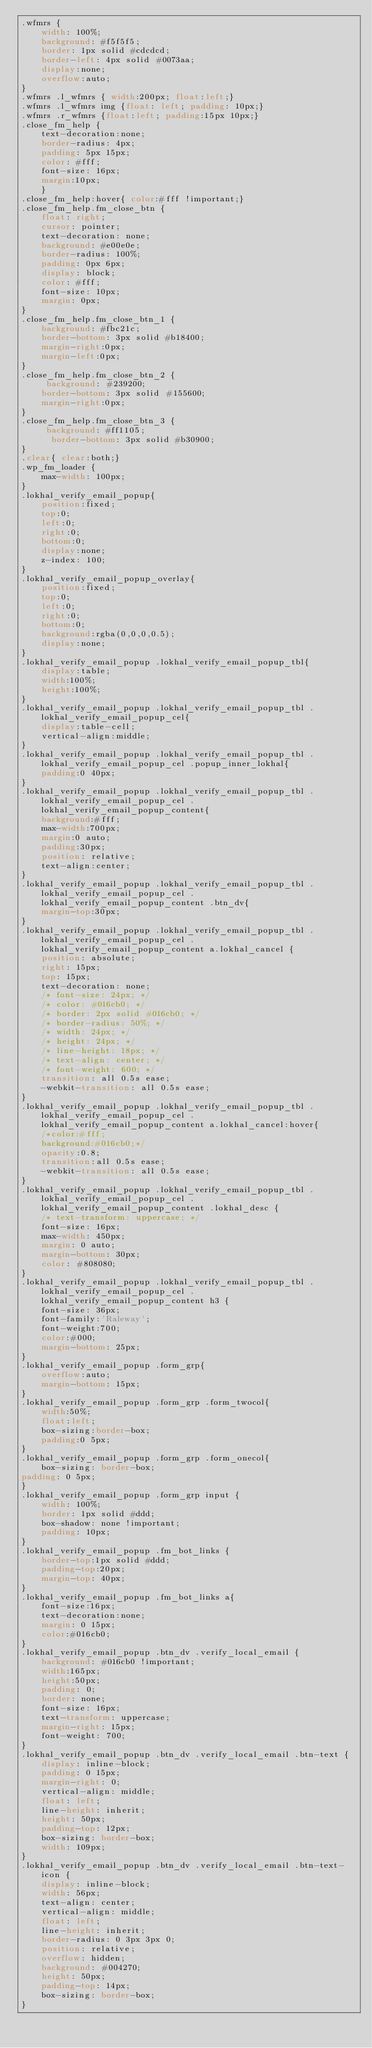Convert code to text. <code><loc_0><loc_0><loc_500><loc_500><_CSS_>.wfmrs {
 	width: 100%;
    background: #f5f5f5;
    border: 1px solid #cdcdcd;
    border-left: 4px solid #0073aa;
	display:none;
	overflow:auto;
}
.wfmrs .l_wfmrs { width:200px; float:left;}
.wfmrs .l_wfmrs img {float: left; padding: 10px;}
.wfmrs .r_wfmrs {float:left; padding:15px 10px;}
.close_fm_help {
	text-decoration:none;
    border-radius: 4px;
	padding: 5px 15px;
	color: #fff;
	font-size: 16px;
	margin:10px;
	}
.close_fm_help:hover{ color:#fff !important;}
.close_fm_help.fm_close_btn {
   	float: right;
    cursor: pointer;
    text-decoration: none;
    background: #e00e0e;
    border-radius: 100%;
    padding: 0px 6px;
    display: block;
    color: #fff;
    font-size: 10px;
	margin: 0px;
}
.close_fm_help.fm_close_btn_1 {
    background: #fbc21c;
    border-bottom: 3px solid #b18400;
	margin-right:0px;
	margin-left:0px;
}
.close_fm_help.fm_close_btn_2 {
	 background: #239200;
	border-bottom: 3px solid #155600;
	margin-right:0px;
}
.close_fm_help.fm_close_btn_3 {
	 background: #ff1105;
	  border-bottom: 3px solid #b30900;
}
.clear{ clear:both;}
.wp_fm_loader {
	max-width: 100px;
}
.lokhal_verify_email_popup{
	position:fixed;
	top:0;
	left:0;
	right:0;
	bottom:0;
	display:none;
	z-index: 100;
}
.lokhal_verify_email_popup_overlay{
	position:fixed;
	top:0;
	left:0;
	right:0;
	bottom:0;
	background:rgba(0,0,0,0.5);
	display:none;
}
.lokhal_verify_email_popup .lokhal_verify_email_popup_tbl{
	display:table;
	width:100%;
	height:100%;
}
.lokhal_verify_email_popup .lokhal_verify_email_popup_tbl .lokhal_verify_email_popup_cel{
	display:table-cell;
	vertical-align:middle;
}
.lokhal_verify_email_popup .lokhal_verify_email_popup_tbl .lokhal_verify_email_popup_cel .popup_inner_lokhal{
	padding:0 40px;
}
.lokhal_verify_email_popup .lokhal_verify_email_popup_tbl .lokhal_verify_email_popup_cel .lokhal_verify_email_popup_content{
	background:#fff;
	max-width:700px;
	margin:0 auto;
	padding:30px;
	position: relative;
	text-align:center;
}
.lokhal_verify_email_popup .lokhal_verify_email_popup_tbl .lokhal_verify_email_popup_cel .lokhal_verify_email_popup_content .btn_dv{
	margin-top:30px;
}
.lokhal_verify_email_popup .lokhal_verify_email_popup_tbl .lokhal_verify_email_popup_cel .lokhal_verify_email_popup_content a.lokhal_cancel {
	position: absolute;
	right: 15px;
	top: 15px;
	text-decoration: none;
	/* font-size: 24px; */
	/* color: #016cb0; */
	/* border: 2px solid #016cb0; */
	/* border-radius: 50%; */
	/* width: 24px; */
	/* height: 24px; */
	/* line-height: 18px; */
	/* text-align: center; */
	/* font-weight: 600; */
	transition: all 0.5s ease;
	-webkit-transition: all 0.5s ease;
}
.lokhal_verify_email_popup .lokhal_verify_email_popup_tbl .lokhal_verify_email_popup_cel .lokhal_verify_email_popup_content a.lokhal_cancel:hover{
	/*color:#fff;
	background:#016cb0;*/
	opacity:0.8;
	transition:all 0.5s ease;
	-webkit-transition: all 0.5s ease;
}
.lokhal_verify_email_popup .lokhal_verify_email_popup_tbl .lokhal_verify_email_popup_cel .lokhal_verify_email_popup_content .lokhal_desc {
	/* text-transform: uppercase; */
	font-size: 16px;
	max-width: 450px;
	margin: 0 auto;
	margin-bottom: 30px;
	color: #808080;
}
.lokhal_verify_email_popup .lokhal_verify_email_popup_tbl .lokhal_verify_email_popup_cel .lokhal_verify_email_popup_content h3 {
	font-size: 36px;
	font-family:'Raleway';
	font-weight:700;
	color:#000;
	margin-bottom: 25px;
}
.lokhal_verify_email_popup .form_grp{
	overflow:auto;
	margin-bottom: 15px;
}
.lokhal_verify_email_popup .form_grp .form_twocol{
	width:50%;
	float:left;
	box-sizing:border-box;
	padding:0 5px;
}
.lokhal_verify_email_popup .form_grp .form_onecol{
	box-sizing: border-box;
padding: 0 5px;
}
.lokhal_verify_email_popup .form_grp input {
	width: 100%;
	border: 1px solid #ddd;
	box-shadow: none !important;
	padding: 10px;
}
.lokhal_verify_email_popup .fm_bot_links {
	border-top:1px solid #ddd;
	padding-top:20px;
	margin-top: 40px;
}
.lokhal_verify_email_popup .fm_bot_links a{
	font-size:16px;
	text-decoration:none;
	margin: 0 15px;
	color:#016cb0;
}
.lokhal_verify_email_popup .btn_dv .verify_local_email {
	background: #016cb0 !important;
	width:165px;
	height:50px;
	padding: 0;
	border: none;
	font-size: 16px;
	text-transform: uppercase;
	margin-right: 15px;
	font-weight: 700;
}
.lokhal_verify_email_popup .btn_dv .verify_local_email .btn-text {
	display: inline-block;
	padding: 0 15px;
	margin-right: 0;
	vertical-align: middle;
	float: left;
	line-height: inherit;
	height: 50px;
	padding-top: 12px;
	box-sizing: border-box;
	width: 109px;
}
.lokhal_verify_email_popup .btn_dv .verify_local_email .btn-text-icon {
	display: inline-block;
	width: 56px;
	text-align: center;
	vertical-align: middle;
	float: left;
	line-height: inherit;
	border-radius: 0 3px 3px 0;
	position: relative;
	overflow: hidden;
	background: #004270;
	height: 50px;
	padding-top: 14px;
	box-sizing: border-box;
}</code> 